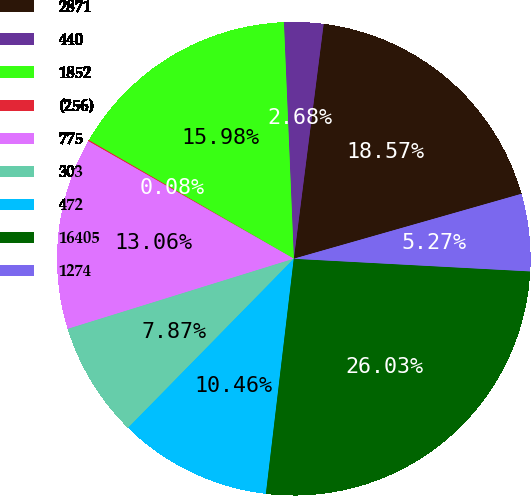Convert chart to OTSL. <chart><loc_0><loc_0><loc_500><loc_500><pie_chart><fcel>2871<fcel>440<fcel>1852<fcel>(256)<fcel>775<fcel>303<fcel>472<fcel>16405<fcel>1274<nl><fcel>18.57%<fcel>2.68%<fcel>15.98%<fcel>0.08%<fcel>13.06%<fcel>7.87%<fcel>10.46%<fcel>26.03%<fcel>5.27%<nl></chart> 